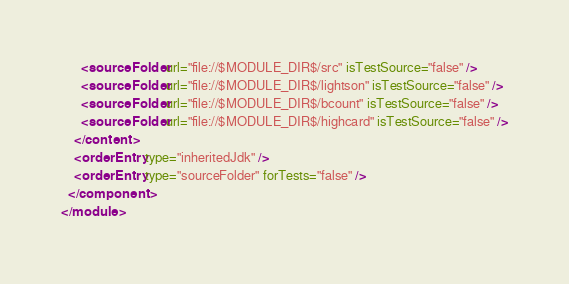<code> <loc_0><loc_0><loc_500><loc_500><_XML_>      <sourceFolder url="file://$MODULE_DIR$/src" isTestSource="false" />
      <sourceFolder url="file://$MODULE_DIR$/lightson" isTestSource="false" />
      <sourceFolder url="file://$MODULE_DIR$/bcount" isTestSource="false" />
      <sourceFolder url="file://$MODULE_DIR$/highcard" isTestSource="false" />
    </content>
    <orderEntry type="inheritedJdk" />
    <orderEntry type="sourceFolder" forTests="false" />
  </component>
</module></code> 